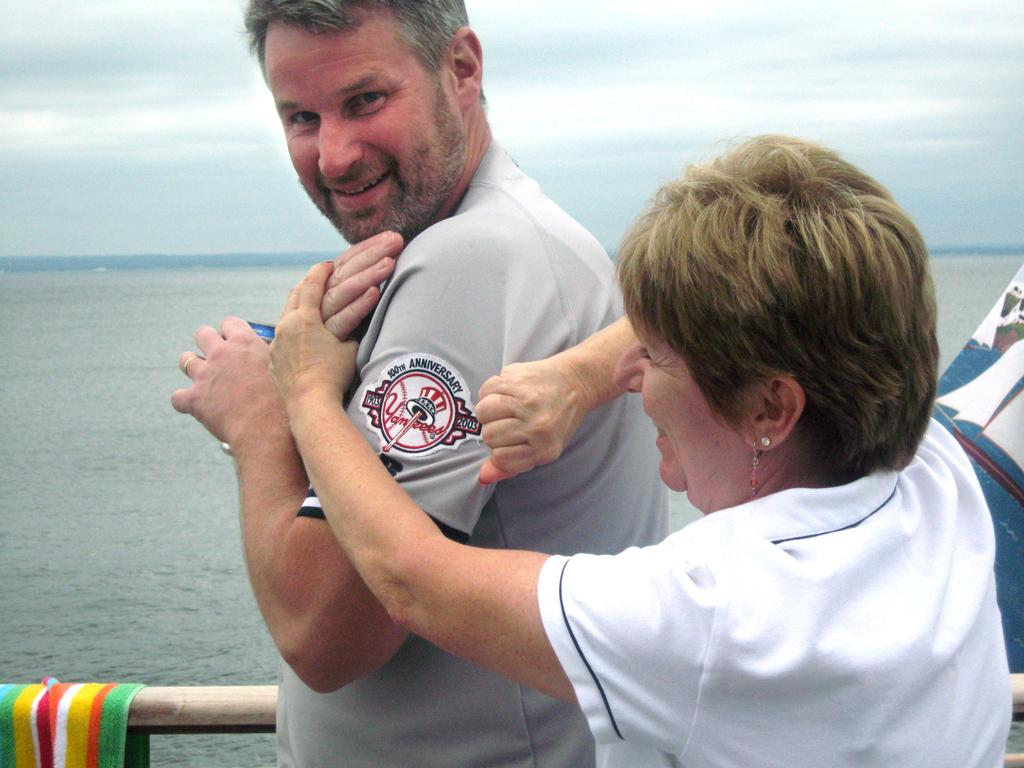<image>
Present a compact description of the photo's key features. a Yankees logo on the side of a man 